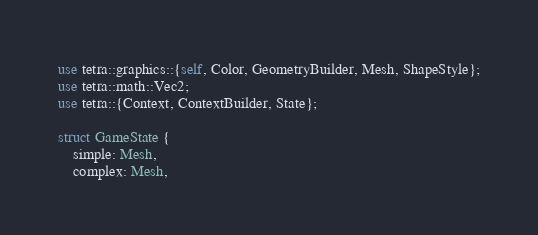Convert code to text. <code><loc_0><loc_0><loc_500><loc_500><_Rust_>use tetra::graphics::{self, Color, GeometryBuilder, Mesh, ShapeStyle};
use tetra::math::Vec2;
use tetra::{Context, ContextBuilder, State};

struct GameState {
    simple: Mesh,
    complex: Mesh,</code> 